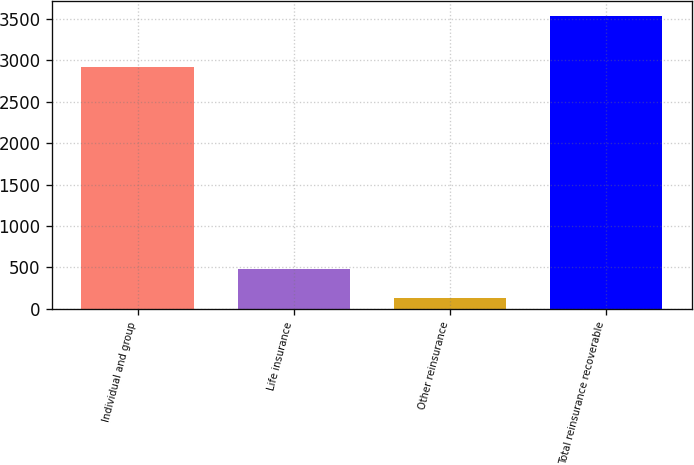<chart> <loc_0><loc_0><loc_500><loc_500><bar_chart><fcel>Individual and group<fcel>Life insurance<fcel>Other reinsurance<fcel>Total reinsurance recoverable<nl><fcel>2917<fcel>484<fcel>135<fcel>3536<nl></chart> 